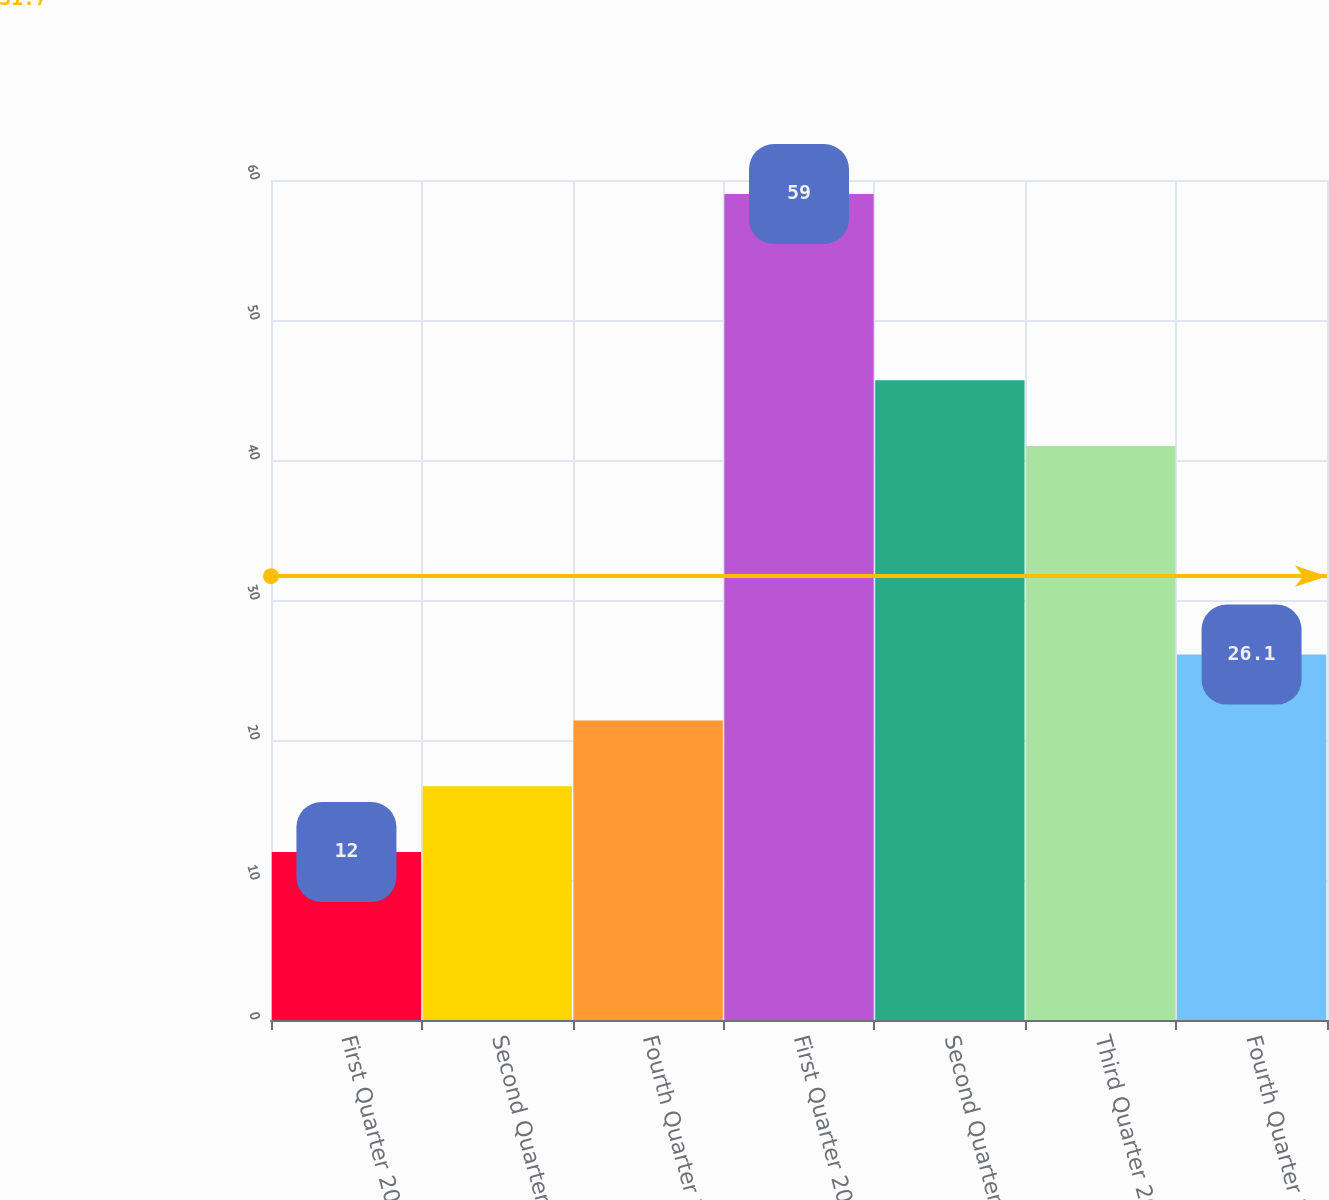<chart> <loc_0><loc_0><loc_500><loc_500><bar_chart><fcel>First Quarter 2010<fcel>Second Quarter 2010<fcel>Fourth Quarter 2010<fcel>First Quarter 2009<fcel>Second Quarter 2009<fcel>Third Quarter 2009<fcel>Fourth Quarter 2009<nl><fcel>12<fcel>16.7<fcel>21.4<fcel>59<fcel>45.7<fcel>41<fcel>26.1<nl></chart> 